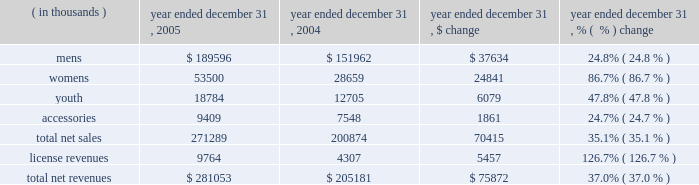Year ended december 31 , 2005 compared to year ended december 31 , 2004 net revenues increased $ 75.9 million , or 37.0% ( 37.0 % ) , to $ 281.1 million in 2005 from $ 205.2 million in 2004 .
This increase was the result of increases in both our net sales and license revenues as noted in the product category table below. .
Net sales increased $ 70.4 million , or 35.1% ( 35.1 % ) , to $ 271.3 million in 2005 from $ 200.9 million in 2004 as noted in the table above .
The increases in the mens , womens and youth product categories noted above primarily reflect : 2022 continued unit volume growth of our existing products sold to retail customers , while pricing of existing products remained relatively unchanged ; and 2022 new products introduced in 2005 accounted for $ 29.0 million of the increase in net sales which included the metal series , under armour tech-t line and our performance hooded sweatshirt for mens , womens and youth , and our new women 2019s duplicity sports bra .
License revenues increased $ 5.5 million to $ 9.8 million in 2005 from $ 4.3 million in 2004 .
This increase in license revenues was a result of increased sales by our licensees due to increased distribution , continued unit volume growth and new product offerings .
Gross profit increased $ 40.5 million to $ 135.9 million in 2005 from $ 95.4 million in 2004 .
Gross profit as a percentage of net revenues , or gross margin , increased 180 basis points to 48.3% ( 48.3 % ) in 2005 from 46.5% ( 46.5 % ) in 2004 .
This net increase in gross margin was primarily driven by the following : 2022 a 70 basis point increase due to the $ 5.5 million increase in license revenues ; 2022 a 240 basis point increase due to lower product costs as a result of greater supplier discounts for increased volume and lower cost sourcing arrangements ; 2022 a 50 basis point decrease driven by larger customer incentives , partially offset by more accurate demand forecasting and better inventory management ; and 2022 a 70 basis point decrease due to higher handling costs to make products to customer specifications for immediate display in their stores and higher overhead costs associated with our quick-turn , special make-up shop , which was instituted in june 2004 .
Selling , general and administrative expenses increased $ 29.9 million , or 42.7% ( 42.7 % ) , to $ 100.0 million in 2005 from $ 70.1 million in 2004 .
As a percentage of net revenues , selling , general and administrative expenses increased to 35.6% ( 35.6 % ) in 2005 from 34.1% ( 34.1 % ) in 2004 .
This net increase was primarily driven by the following : 2022 marketing costs increased $ 8.7 million to $ 30.5 million in 2005 from $ 21.8 million in 2004 .
The increase in these costs was due to increased advertising costs from our women 2019s media campaign , marketing salaries , and depreciation expense related to our in-store fixture program .
As a percentage of net revenues , marketing costs increased slightly to 10.9% ( 10.9 % ) in 2005 from 10.6% ( 10.6 % ) in 2004 due to the increased costs described above. .
What was the percent of growth in gross profit from 2004 to 2005\\n? 
Computations: (40.5 / 95.4)
Answer: 0.42453. 